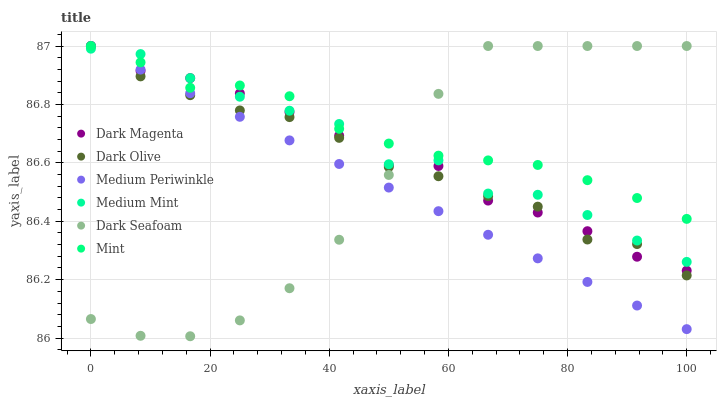Does Medium Periwinkle have the minimum area under the curve?
Answer yes or no. Yes. Does Mint have the maximum area under the curve?
Answer yes or no. Yes. Does Dark Magenta have the minimum area under the curve?
Answer yes or no. No. Does Dark Magenta have the maximum area under the curve?
Answer yes or no. No. Is Medium Periwinkle the smoothest?
Answer yes or no. Yes. Is Medium Mint the roughest?
Answer yes or no. Yes. Is Dark Magenta the smoothest?
Answer yes or no. No. Is Dark Magenta the roughest?
Answer yes or no. No. Does Dark Seafoam have the lowest value?
Answer yes or no. Yes. Does Dark Magenta have the lowest value?
Answer yes or no. No. Does Mint have the highest value?
Answer yes or no. Yes. Does Dark Olive intersect Mint?
Answer yes or no. Yes. Is Dark Olive less than Mint?
Answer yes or no. No. Is Dark Olive greater than Mint?
Answer yes or no. No. 